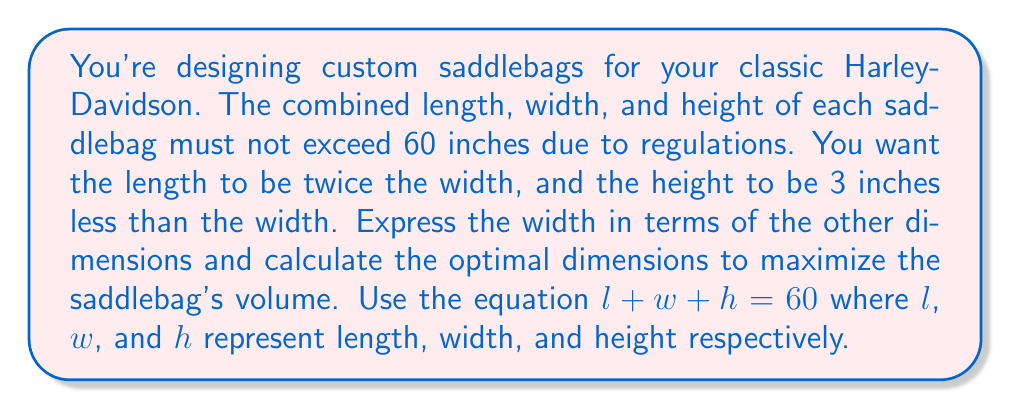Provide a solution to this math problem. 1) Given constraints:
   $l + w + h = 60$
   $l = 2w$
   $h = w - 3$

2) Substitute $l$ and $h$ into the main equation:
   $2w + w + (w - 3) = 60$

3) Simplify:
   $4w - 3 = 60$

4) Solve for $w$:
   $4w = 63$
   $w = 15.75$ inches

5) Calculate $l$ and $h$:
   $l = 2w = 2(15.75) = 31.5$ inches
   $h = w - 3 = 15.75 - 3 = 12.75$ inches

6) Verify the constraint:
   $31.5 + 15.75 + 12.75 = 60$ inches

7) Calculate the volume:
   $V = l * w * h = 31.5 * 15.75 * 12.75 = 6,320.15625$ cubic inches

These dimensions maximize the volume while satisfying the constraints.
Answer: Length: 31.5 inches, Width: 15.75 inches, Height: 12.75 inches 